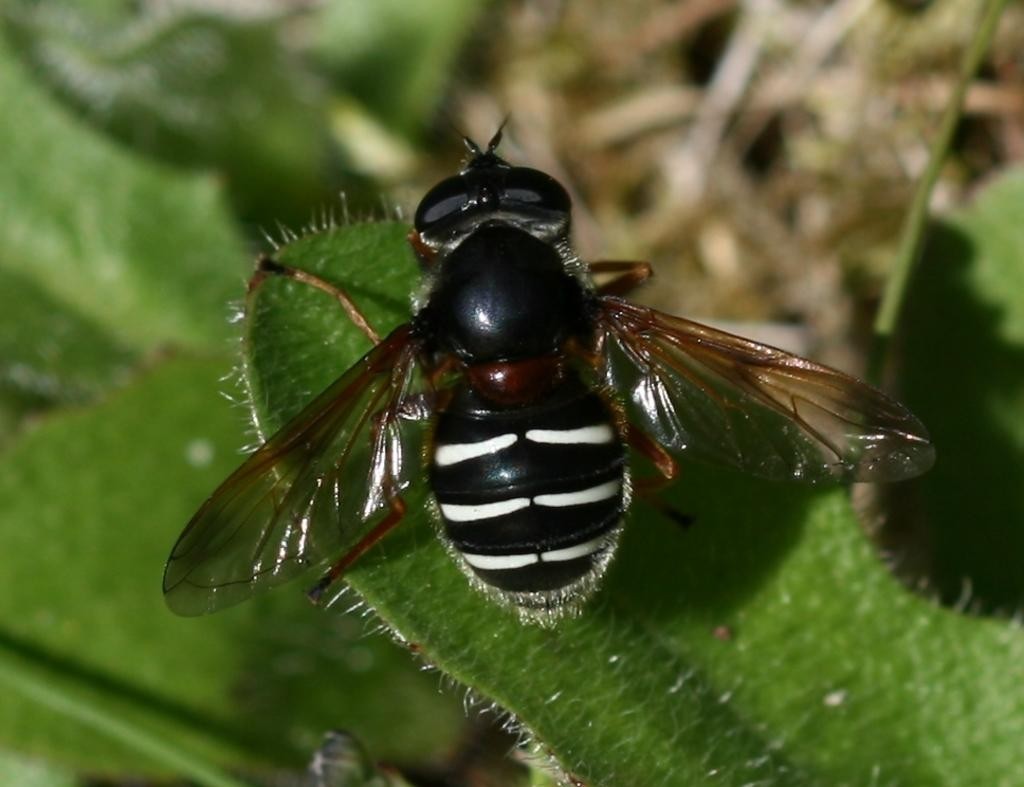What is present on the green leaf in the image? There is an insect on a green leaf in the image. Can you describe the background of the image? The background of the image is blurred. What type of hose is being played by the insect in the image? There is no hose present in the image; it features an insect on a green leaf with a blurred background. Can you tell me what color the guitar is in the image? There is no guitar present in the image; it features an insect on a green leaf with a blurred background. 